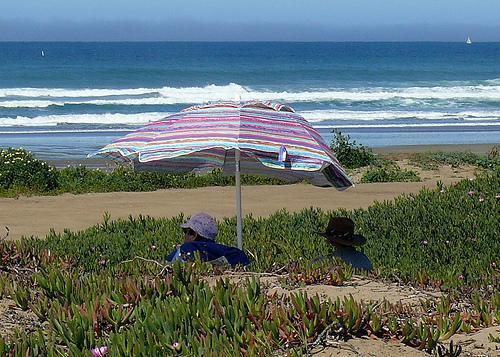How many people can be seen?
Give a very brief answer. 2. 